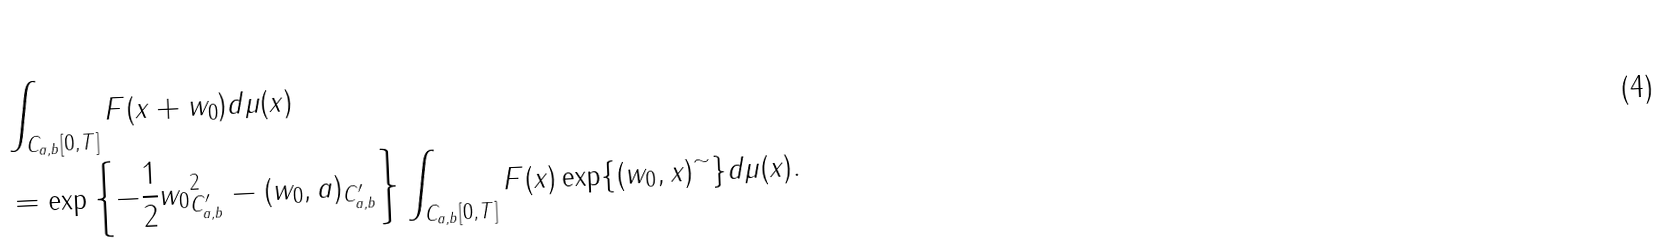Convert formula to latex. <formula><loc_0><loc_0><loc_500><loc_500>& \int _ { C _ { a , b } [ 0 , T ] } F ( x + w _ { 0 } ) d \mu ( x ) \\ & = \exp \left \{ - \frac { 1 } { 2 } \| w _ { 0 } \| _ { C _ { a , b } ^ { \prime } } ^ { 2 } - ( w _ { 0 } , a ) _ { C _ { a , b } ^ { \prime } } \right \} \int _ { C _ { a , b } [ 0 , T ] } F ( x ) \exp \{ ( w _ { 0 } , x ) ^ { \sim } \} d \mu ( x ) .</formula> 